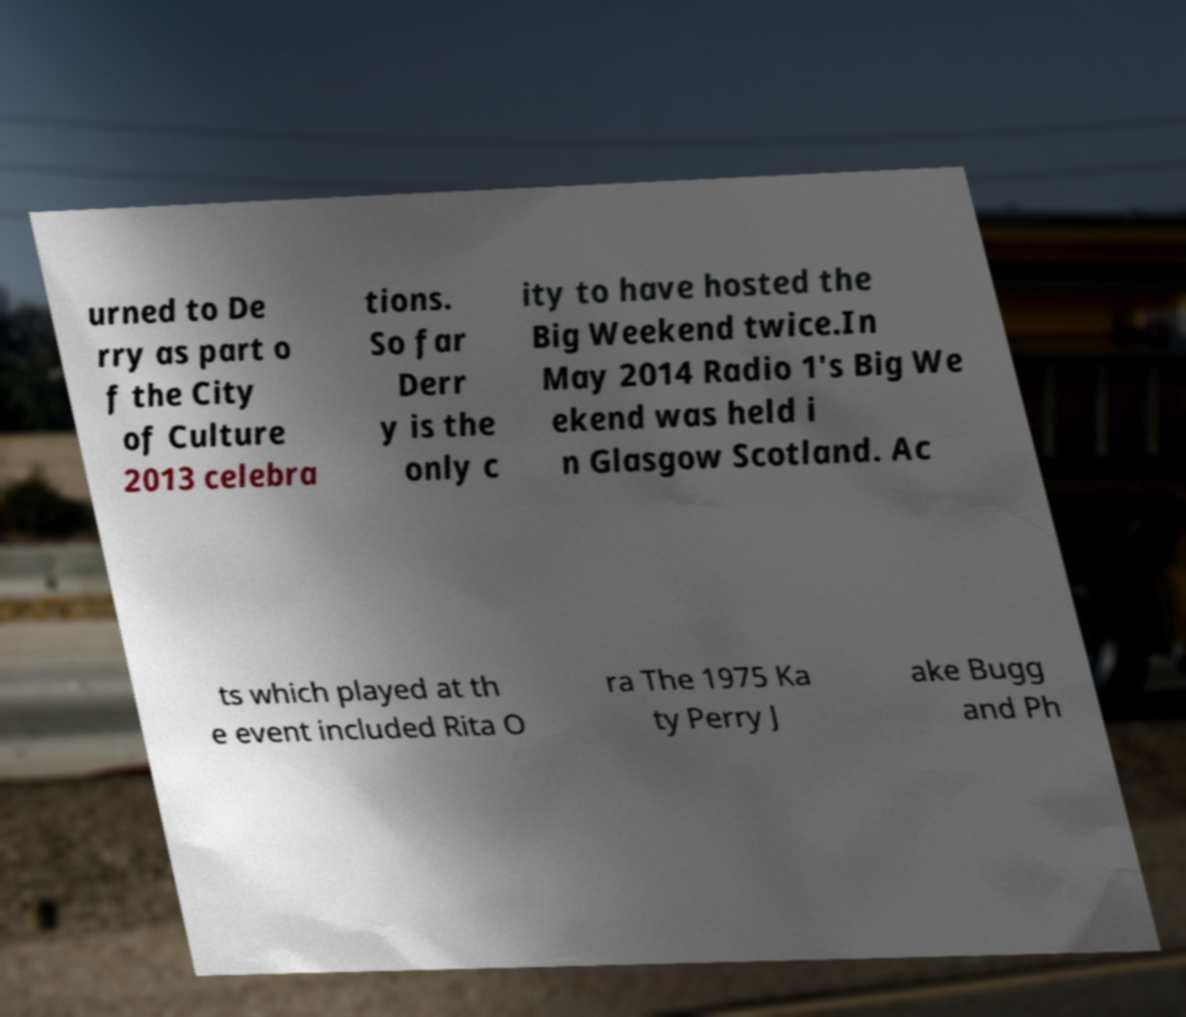Can you accurately transcribe the text from the provided image for me? urned to De rry as part o f the City of Culture 2013 celebra tions. So far Derr y is the only c ity to have hosted the Big Weekend twice.In May 2014 Radio 1's Big We ekend was held i n Glasgow Scotland. Ac ts which played at th e event included Rita O ra The 1975 Ka ty Perry J ake Bugg and Ph 